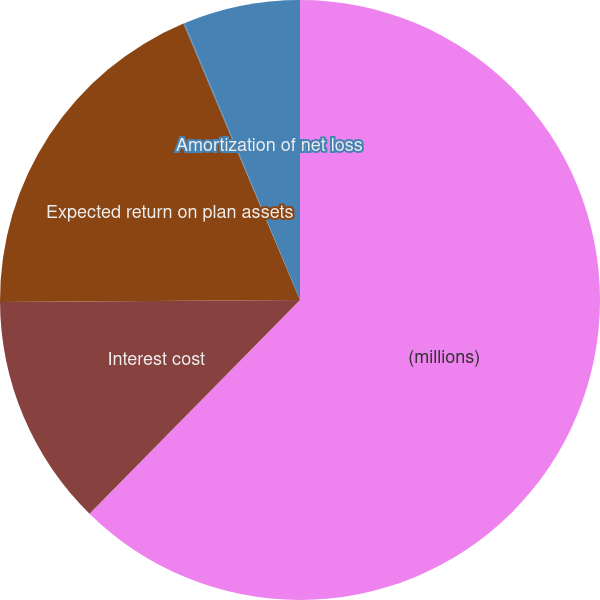Convert chart to OTSL. <chart><loc_0><loc_0><loc_500><loc_500><pie_chart><fcel>(millions)<fcel>Interest cost<fcel>Expected return on plan assets<fcel>Amortization of prior-service<fcel>Amortization of net loss<nl><fcel>62.37%<fcel>12.52%<fcel>18.75%<fcel>0.06%<fcel>6.29%<nl></chart> 